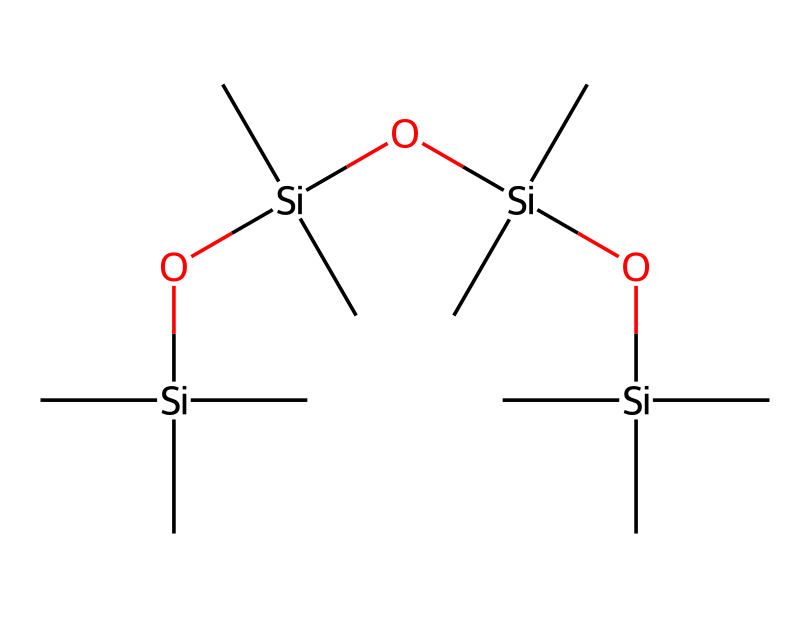What is the main element present in this chemical structure? By analyzing the SMILES representation, we can observe that the backbone consists of silicon atoms (Si) interspersed with oxygen atoms (O) and carbon atoms (C). The predominant element is silicon.
Answer: silicon How many silicon atoms are in the structure? The SMILES representation reveals that there are four distinct silicon atoms (Si) present, inferred from the segments where they are positioned in the chain.
Answer: four What functional groups are present in this chemical? The presence of -Si- and -O- connections indicates that this chemical has siloxane (-Si-O-Si-) linkages, which are characteristic functional groups in silicone compounds.
Answer: siloxane How many carbon atoms are attached to each silicon atom in the structure? Each silicon atom (Si) in the provided structure is connected to three carbon atoms (C), as indicated by the repetition of -C in the SMILES.
Answer: three Is this chemical likely to be soluble in water? The siloxane structure and long hydrocarbon chains suggest that this compound is hydrophobic, meaning it is not soluble in water due to its silicon backbone and carbon attachments.
Answer: no What property does the arrangement of silicone atoms suggest about the lubricant's effectiveness? The alternating silicon and oxygen atoms create a flexible and stable structure that enhances lubricant properties by reducing surface tension and increasing spreadability, which enhances effectiveness.
Answer: effective 